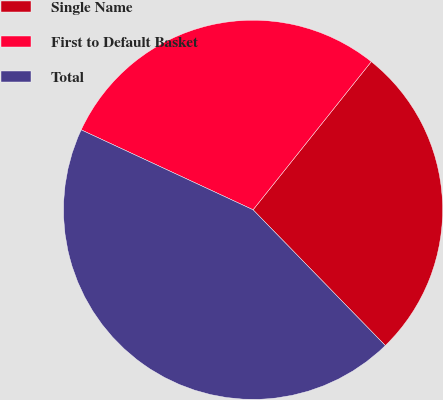<chart> <loc_0><loc_0><loc_500><loc_500><pie_chart><fcel>Single Name<fcel>First to Default Basket<fcel>Total<nl><fcel>26.99%<fcel>28.79%<fcel>44.22%<nl></chart> 